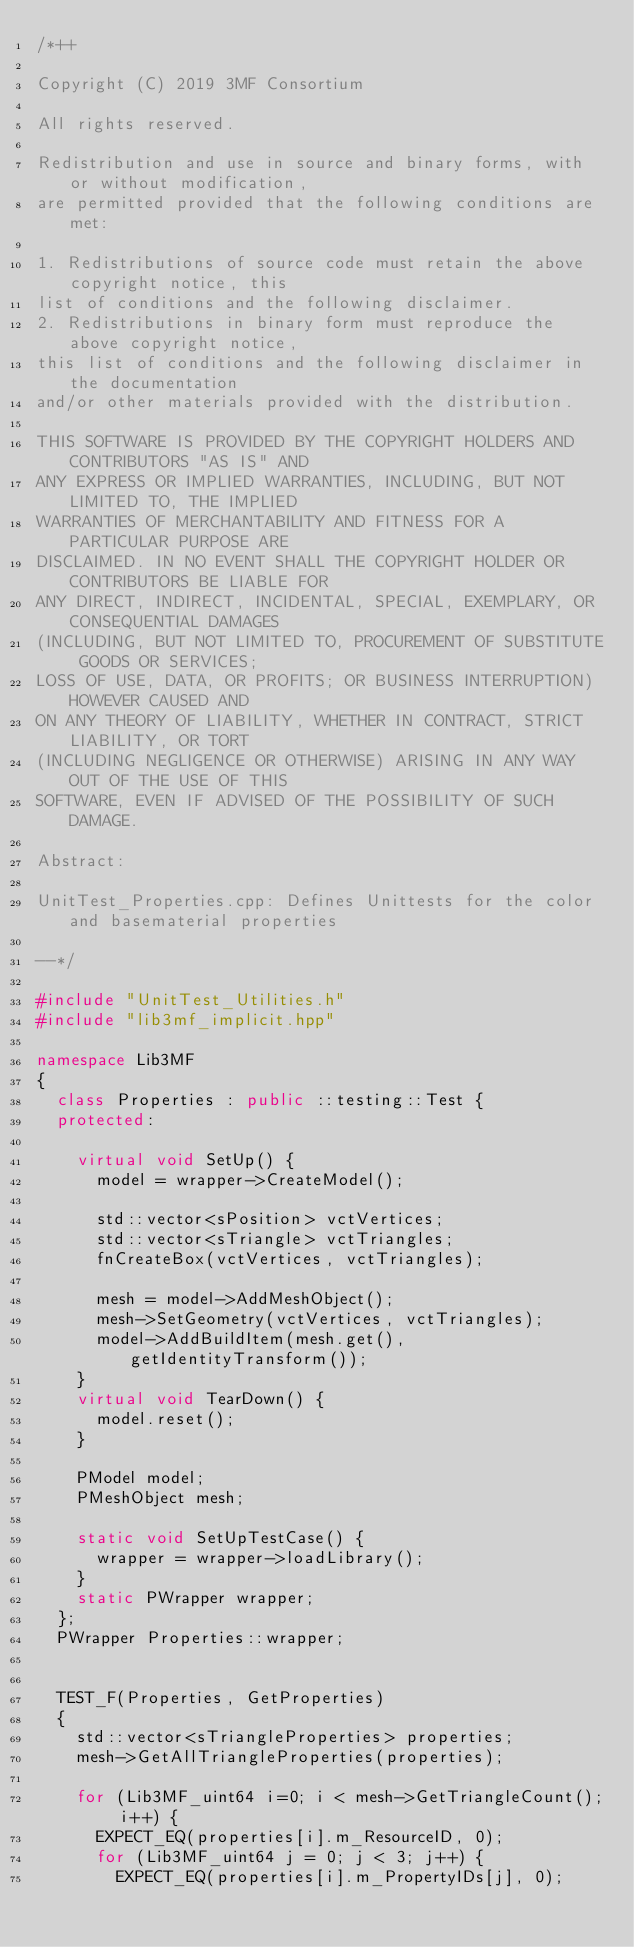<code> <loc_0><loc_0><loc_500><loc_500><_C++_>/*++

Copyright (C) 2019 3MF Consortium

All rights reserved.

Redistribution and use in source and binary forms, with or without modification,
are permitted provided that the following conditions are met:

1. Redistributions of source code must retain the above copyright notice, this
list of conditions and the following disclaimer.
2. Redistributions in binary form must reproduce the above copyright notice,
this list of conditions and the following disclaimer in the documentation
and/or other materials provided with the distribution.

THIS SOFTWARE IS PROVIDED BY THE COPYRIGHT HOLDERS AND CONTRIBUTORS "AS IS" AND
ANY EXPRESS OR IMPLIED WARRANTIES, INCLUDING, BUT NOT LIMITED TO, THE IMPLIED
WARRANTIES OF MERCHANTABILITY AND FITNESS FOR A PARTICULAR PURPOSE ARE
DISCLAIMED. IN NO EVENT SHALL THE COPYRIGHT HOLDER OR CONTRIBUTORS BE LIABLE FOR
ANY DIRECT, INDIRECT, INCIDENTAL, SPECIAL, EXEMPLARY, OR CONSEQUENTIAL DAMAGES
(INCLUDING, BUT NOT LIMITED TO, PROCUREMENT OF SUBSTITUTE GOODS OR SERVICES;
LOSS OF USE, DATA, OR PROFITS; OR BUSINESS INTERRUPTION) HOWEVER CAUSED AND
ON ANY THEORY OF LIABILITY, WHETHER IN CONTRACT, STRICT LIABILITY, OR TORT
(INCLUDING NEGLIGENCE OR OTHERWISE) ARISING IN ANY WAY OUT OF THE USE OF THIS
SOFTWARE, EVEN IF ADVISED OF THE POSSIBILITY OF SUCH DAMAGE.

Abstract:

UnitTest_Properties.cpp: Defines Unittests for the color and basematerial properties

--*/

#include "UnitTest_Utilities.h"
#include "lib3mf_implicit.hpp"

namespace Lib3MF
{
	class Properties : public ::testing::Test {
	protected:

		virtual void SetUp() {
			model = wrapper->CreateModel();

			std::vector<sPosition> vctVertices;
			std::vector<sTriangle> vctTriangles;
			fnCreateBox(vctVertices, vctTriangles);

			mesh = model->AddMeshObject();
			mesh->SetGeometry(vctVertices, vctTriangles);
			model->AddBuildItem(mesh.get(), getIdentityTransform());
		}
		virtual void TearDown() {
			model.reset();
		}

		PModel model;
		PMeshObject mesh;

		static void SetUpTestCase() {
			wrapper = wrapper->loadLibrary();
		}
		static PWrapper wrapper;
	};
	PWrapper Properties::wrapper;


	TEST_F(Properties, GetProperties)
	{
		std::vector<sTriangleProperties> properties;
		mesh->GetAllTriangleProperties(properties);

		for (Lib3MF_uint64 i=0; i < mesh->GetTriangleCount(); i++) {
			EXPECT_EQ(properties[i].m_ResourceID, 0);
			for (Lib3MF_uint64 j = 0; j < 3; j++) {
				EXPECT_EQ(properties[i].m_PropertyIDs[j], 0);</code> 